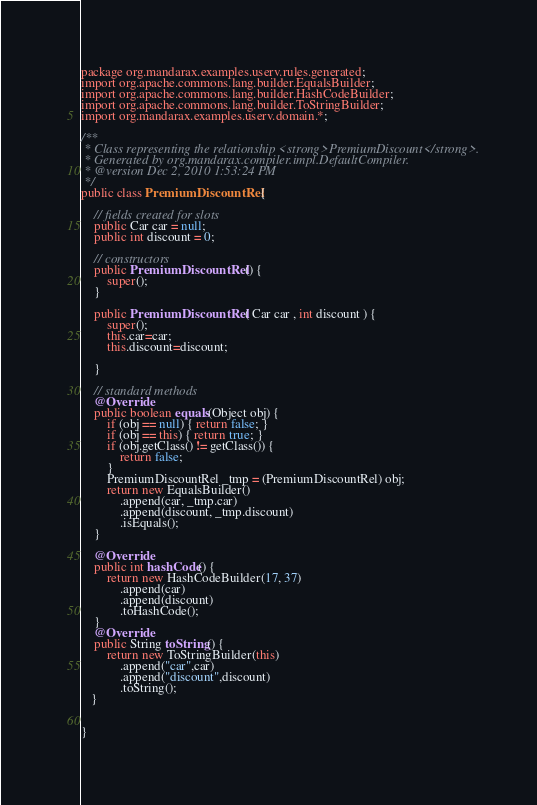<code> <loc_0><loc_0><loc_500><loc_500><_Java_>package org.mandarax.examples.userv.rules.generated;
import org.apache.commons.lang.builder.EqualsBuilder;
import org.apache.commons.lang.builder.HashCodeBuilder;
import org.apache.commons.lang.builder.ToStringBuilder;
import org.mandarax.examples.userv.domain.*;

/**
 * Class representing the relationship <strong>PremiumDiscount</strong>.
 * Generated by org.mandarax.compiler.impl.DefaultCompiler.
 * @version Dec 2, 2010 1:53:24 PM 
 */
public class PremiumDiscountRel {

	// fields created for slots 
	public Car car = null; 
	public int discount = 0;
	
	// constructors
	public PremiumDiscountRel () {
		super();
	}
	
	public PremiumDiscountRel ( Car car , int discount ) {
		super();
		this.car=car; 
		this.discount=discount; 
		
	}

	// standard methods
	@Override
	public boolean equals(Object obj) {
   		if (obj == null) { return false; }
   		if (obj == this) { return true; }
		if (obj.getClass() != getClass()) {
			return false;
		}
   		PremiumDiscountRel _tmp = (PremiumDiscountRel) obj;
   		return new EqualsBuilder()
            .append(car, _tmp.car)
            .append(discount, _tmp.discount)
            .isEquals();
  	}
  
  	@Override
   	public int hashCode() {
    	return new HashCodeBuilder(17, 37)
        	.append(car)
            .append(discount)
            .toHashCode();
   	}
   	@Override
   	public String toString() {
    	return new ToStringBuilder(this)
    		.append("car",car)
    		.append("discount",discount)
    		.toString();
   }
   

}

</code> 